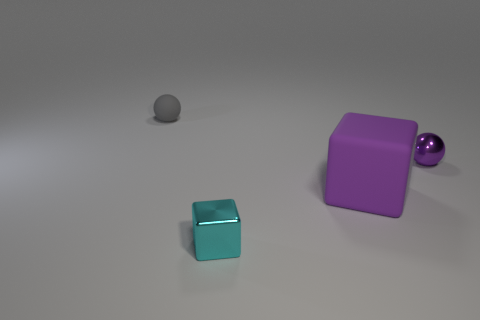Can you describe the surface on which the objects are placed? The surface appears to be a smooth, almost featureless plane with a matte finish, which echoes the understated lighting by providing soft reflections and diffuse shadows.  Compared to the other objects, what does the shadow reveal about the light source? The shadows suggest that the light source is positioned above the scene, and slightly to the right. They are not overly long or distorted, indicating the light source is neither excessively close nor at a sharp angle. 